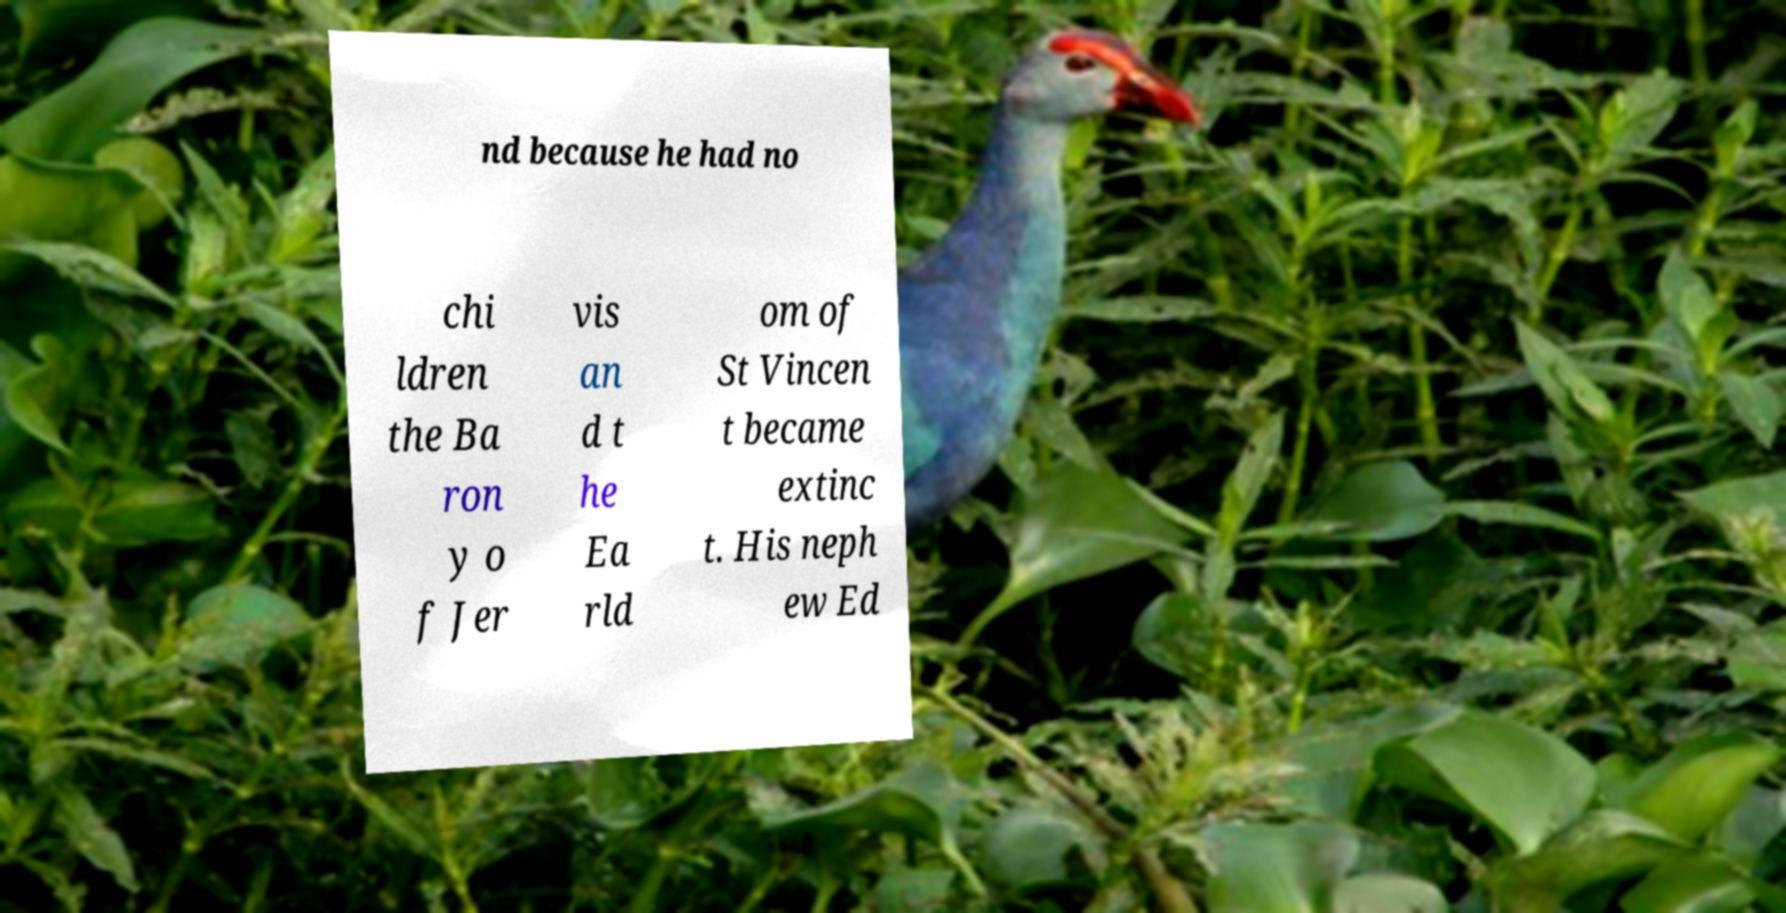Could you extract and type out the text from this image? nd because he had no chi ldren the Ba ron y o f Jer vis an d t he Ea rld om of St Vincen t became extinc t. His neph ew Ed 